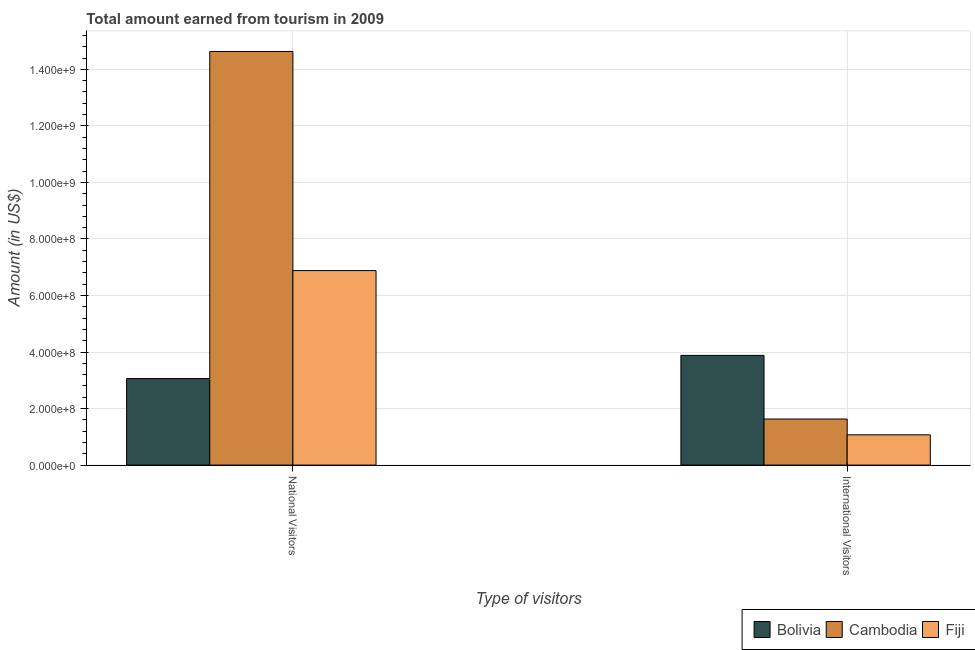How many different coloured bars are there?
Offer a terse response. 3. How many groups of bars are there?
Offer a terse response. 2. How many bars are there on the 2nd tick from the right?
Your response must be concise. 3. What is the label of the 2nd group of bars from the left?
Offer a very short reply. International Visitors. What is the amount earned from national visitors in Fiji?
Offer a terse response. 6.88e+08. Across all countries, what is the maximum amount earned from international visitors?
Your answer should be very brief. 3.88e+08. Across all countries, what is the minimum amount earned from national visitors?
Your answer should be very brief. 3.06e+08. In which country was the amount earned from national visitors maximum?
Provide a succinct answer. Cambodia. In which country was the amount earned from international visitors minimum?
Your answer should be compact. Fiji. What is the total amount earned from national visitors in the graph?
Provide a succinct answer. 2.46e+09. What is the difference between the amount earned from national visitors in Cambodia and that in Fiji?
Provide a succinct answer. 7.75e+08. What is the difference between the amount earned from national visitors in Bolivia and the amount earned from international visitors in Cambodia?
Provide a succinct answer. 1.43e+08. What is the average amount earned from international visitors per country?
Your response must be concise. 2.19e+08. What is the difference between the amount earned from international visitors and amount earned from national visitors in Fiji?
Ensure brevity in your answer.  -5.81e+08. In how many countries, is the amount earned from international visitors greater than 320000000 US$?
Give a very brief answer. 1. What is the ratio of the amount earned from national visitors in Fiji to that in Bolivia?
Offer a terse response. 2.25. Is the amount earned from national visitors in Cambodia less than that in Bolivia?
Give a very brief answer. No. In how many countries, is the amount earned from national visitors greater than the average amount earned from national visitors taken over all countries?
Ensure brevity in your answer.  1. What does the 3rd bar from the left in National Visitors represents?
Provide a short and direct response. Fiji. What does the 1st bar from the right in National Visitors represents?
Offer a terse response. Fiji. How many bars are there?
Provide a short and direct response. 6. How many countries are there in the graph?
Offer a terse response. 3. Does the graph contain any zero values?
Ensure brevity in your answer.  No. How are the legend labels stacked?
Provide a succinct answer. Horizontal. What is the title of the graph?
Provide a short and direct response. Total amount earned from tourism in 2009. What is the label or title of the X-axis?
Your answer should be very brief. Type of visitors. What is the label or title of the Y-axis?
Give a very brief answer. Amount (in US$). What is the Amount (in US$) in Bolivia in National Visitors?
Provide a succinct answer. 3.06e+08. What is the Amount (in US$) of Cambodia in National Visitors?
Make the answer very short. 1.46e+09. What is the Amount (in US$) in Fiji in National Visitors?
Provide a short and direct response. 6.88e+08. What is the Amount (in US$) in Bolivia in International Visitors?
Your answer should be compact. 3.88e+08. What is the Amount (in US$) of Cambodia in International Visitors?
Offer a terse response. 1.63e+08. What is the Amount (in US$) of Fiji in International Visitors?
Ensure brevity in your answer.  1.07e+08. Across all Type of visitors, what is the maximum Amount (in US$) of Bolivia?
Provide a short and direct response. 3.88e+08. Across all Type of visitors, what is the maximum Amount (in US$) of Cambodia?
Your response must be concise. 1.46e+09. Across all Type of visitors, what is the maximum Amount (in US$) in Fiji?
Offer a very short reply. 6.88e+08. Across all Type of visitors, what is the minimum Amount (in US$) in Bolivia?
Keep it short and to the point. 3.06e+08. Across all Type of visitors, what is the minimum Amount (in US$) of Cambodia?
Provide a succinct answer. 1.63e+08. Across all Type of visitors, what is the minimum Amount (in US$) of Fiji?
Provide a succinct answer. 1.07e+08. What is the total Amount (in US$) of Bolivia in the graph?
Provide a succinct answer. 6.94e+08. What is the total Amount (in US$) of Cambodia in the graph?
Offer a terse response. 1.63e+09. What is the total Amount (in US$) in Fiji in the graph?
Offer a terse response. 7.95e+08. What is the difference between the Amount (in US$) in Bolivia in National Visitors and that in International Visitors?
Keep it short and to the point. -8.20e+07. What is the difference between the Amount (in US$) of Cambodia in National Visitors and that in International Visitors?
Offer a terse response. 1.30e+09. What is the difference between the Amount (in US$) of Fiji in National Visitors and that in International Visitors?
Make the answer very short. 5.81e+08. What is the difference between the Amount (in US$) of Bolivia in National Visitors and the Amount (in US$) of Cambodia in International Visitors?
Your answer should be very brief. 1.43e+08. What is the difference between the Amount (in US$) in Bolivia in National Visitors and the Amount (in US$) in Fiji in International Visitors?
Ensure brevity in your answer.  1.99e+08. What is the difference between the Amount (in US$) of Cambodia in National Visitors and the Amount (in US$) of Fiji in International Visitors?
Your answer should be compact. 1.36e+09. What is the average Amount (in US$) in Bolivia per Type of visitors?
Provide a short and direct response. 3.47e+08. What is the average Amount (in US$) in Cambodia per Type of visitors?
Keep it short and to the point. 8.13e+08. What is the average Amount (in US$) of Fiji per Type of visitors?
Your answer should be very brief. 3.98e+08. What is the difference between the Amount (in US$) in Bolivia and Amount (in US$) in Cambodia in National Visitors?
Keep it short and to the point. -1.16e+09. What is the difference between the Amount (in US$) of Bolivia and Amount (in US$) of Fiji in National Visitors?
Make the answer very short. -3.82e+08. What is the difference between the Amount (in US$) in Cambodia and Amount (in US$) in Fiji in National Visitors?
Your answer should be compact. 7.75e+08. What is the difference between the Amount (in US$) in Bolivia and Amount (in US$) in Cambodia in International Visitors?
Your response must be concise. 2.25e+08. What is the difference between the Amount (in US$) in Bolivia and Amount (in US$) in Fiji in International Visitors?
Keep it short and to the point. 2.81e+08. What is the difference between the Amount (in US$) of Cambodia and Amount (in US$) of Fiji in International Visitors?
Your response must be concise. 5.60e+07. What is the ratio of the Amount (in US$) of Bolivia in National Visitors to that in International Visitors?
Offer a very short reply. 0.79. What is the ratio of the Amount (in US$) of Cambodia in National Visitors to that in International Visitors?
Offer a very short reply. 8.98. What is the ratio of the Amount (in US$) of Fiji in National Visitors to that in International Visitors?
Your answer should be compact. 6.43. What is the difference between the highest and the second highest Amount (in US$) of Bolivia?
Ensure brevity in your answer.  8.20e+07. What is the difference between the highest and the second highest Amount (in US$) in Cambodia?
Offer a very short reply. 1.30e+09. What is the difference between the highest and the second highest Amount (in US$) in Fiji?
Your answer should be compact. 5.81e+08. What is the difference between the highest and the lowest Amount (in US$) in Bolivia?
Give a very brief answer. 8.20e+07. What is the difference between the highest and the lowest Amount (in US$) in Cambodia?
Provide a short and direct response. 1.30e+09. What is the difference between the highest and the lowest Amount (in US$) of Fiji?
Give a very brief answer. 5.81e+08. 